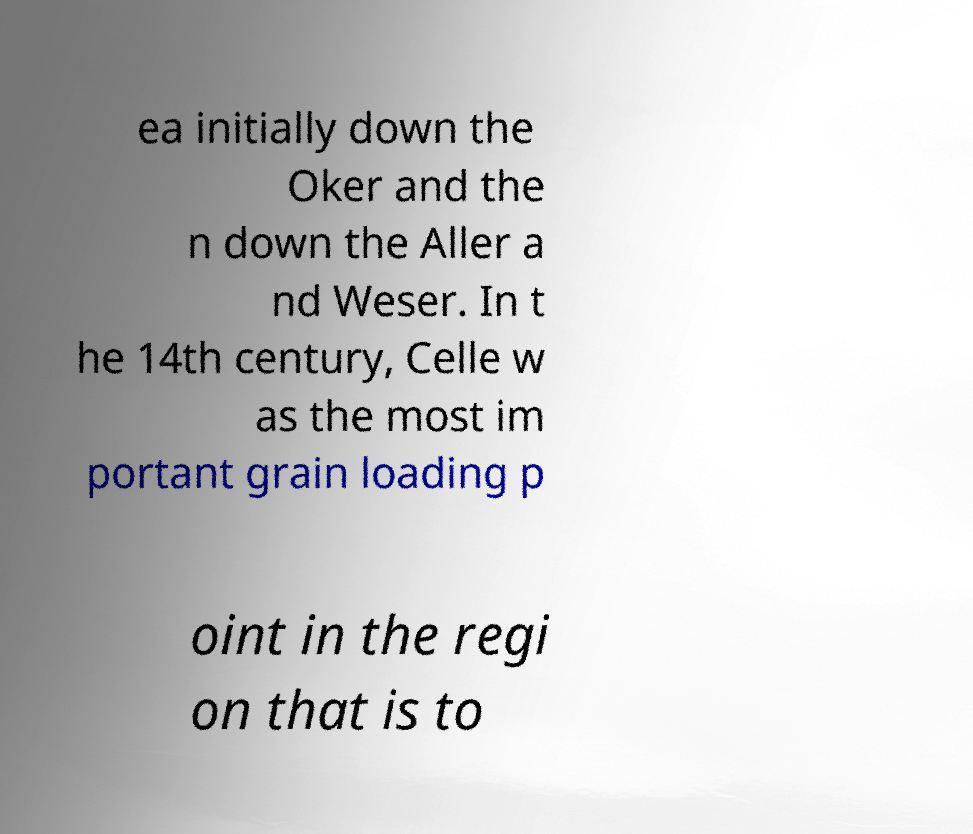What messages or text are displayed in this image? I need them in a readable, typed format. ea initially down the Oker and the n down the Aller a nd Weser. In t he 14th century, Celle w as the most im portant grain loading p oint in the regi on that is to 